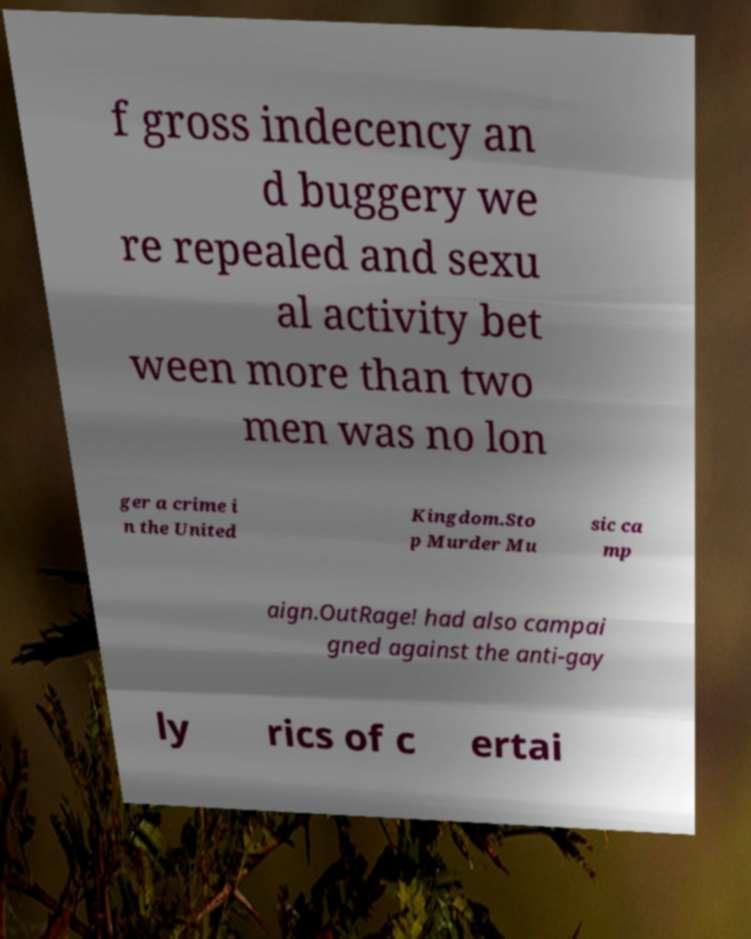Could you assist in decoding the text presented in this image and type it out clearly? f gross indecency an d buggery we re repealed and sexu al activity bet ween more than two men was no lon ger a crime i n the United Kingdom.Sto p Murder Mu sic ca mp aign.OutRage! had also campai gned against the anti-gay ly rics of c ertai 